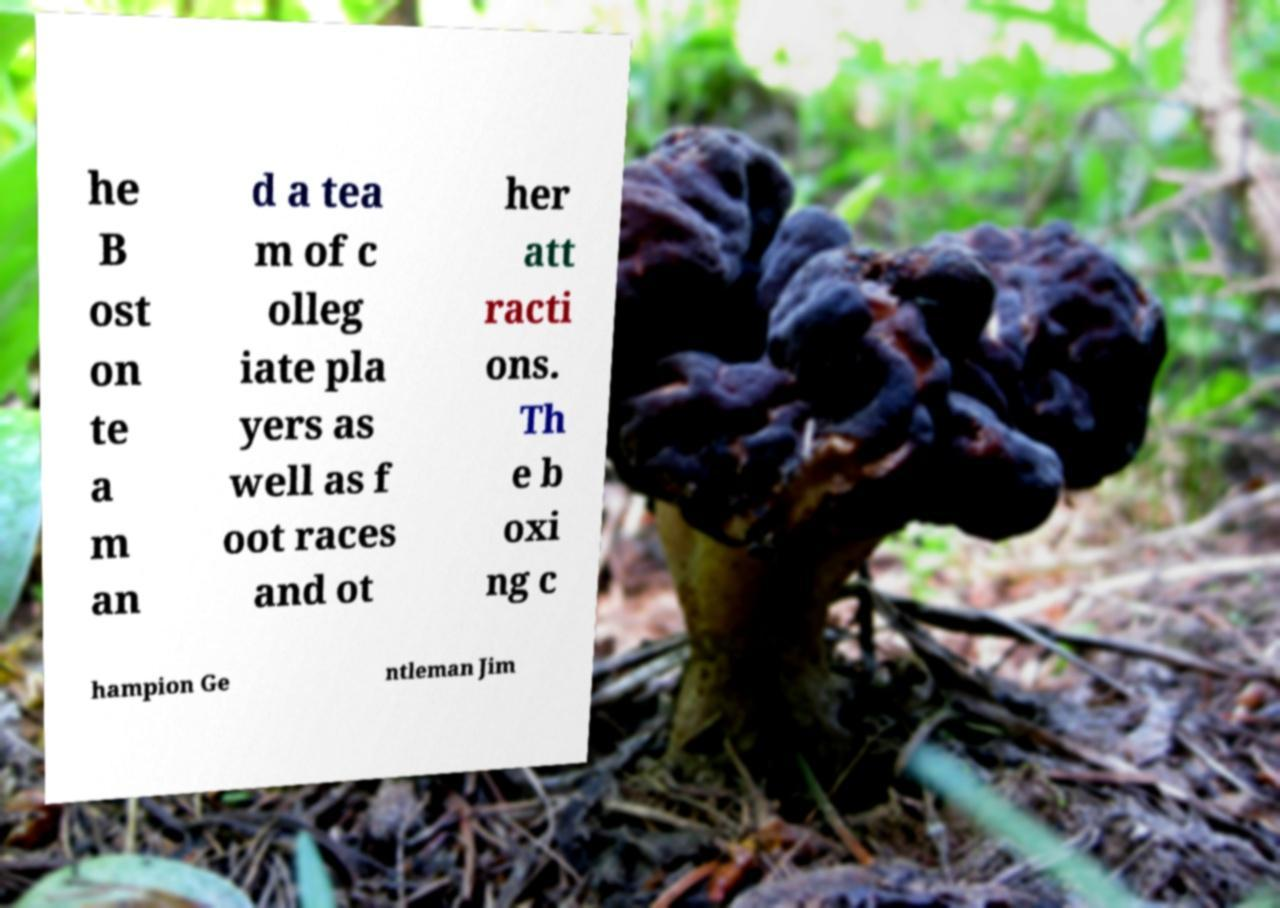Could you extract and type out the text from this image? he B ost on te a m an d a tea m of c olleg iate pla yers as well as f oot races and ot her att racti ons. Th e b oxi ng c hampion Ge ntleman Jim 